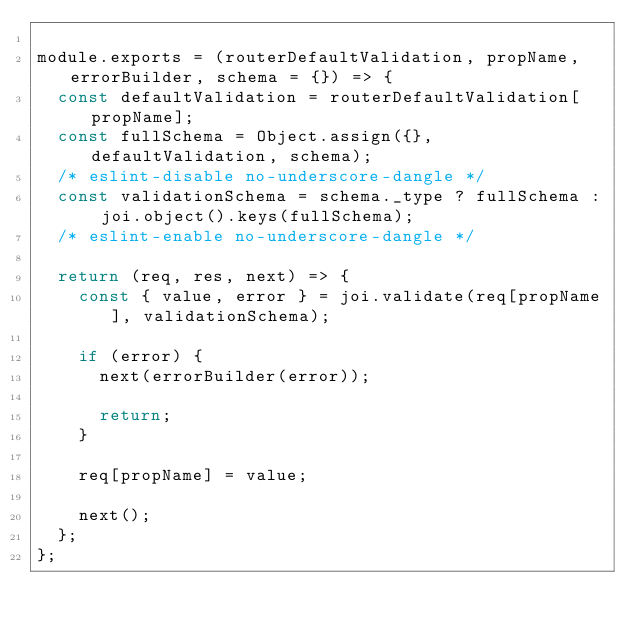Convert code to text. <code><loc_0><loc_0><loc_500><loc_500><_JavaScript_>
module.exports = (routerDefaultValidation, propName, errorBuilder, schema = {}) => {
  const defaultValidation = routerDefaultValidation[propName];
  const fullSchema = Object.assign({}, defaultValidation, schema);
  /* eslint-disable no-underscore-dangle */
  const validationSchema = schema._type ? fullSchema : joi.object().keys(fullSchema);
  /* eslint-enable no-underscore-dangle */

  return (req, res, next) => {
    const { value, error } = joi.validate(req[propName], validationSchema);

    if (error) {
      next(errorBuilder(error));

      return;
    }

    req[propName] = value;

    next();
  };
};
</code> 